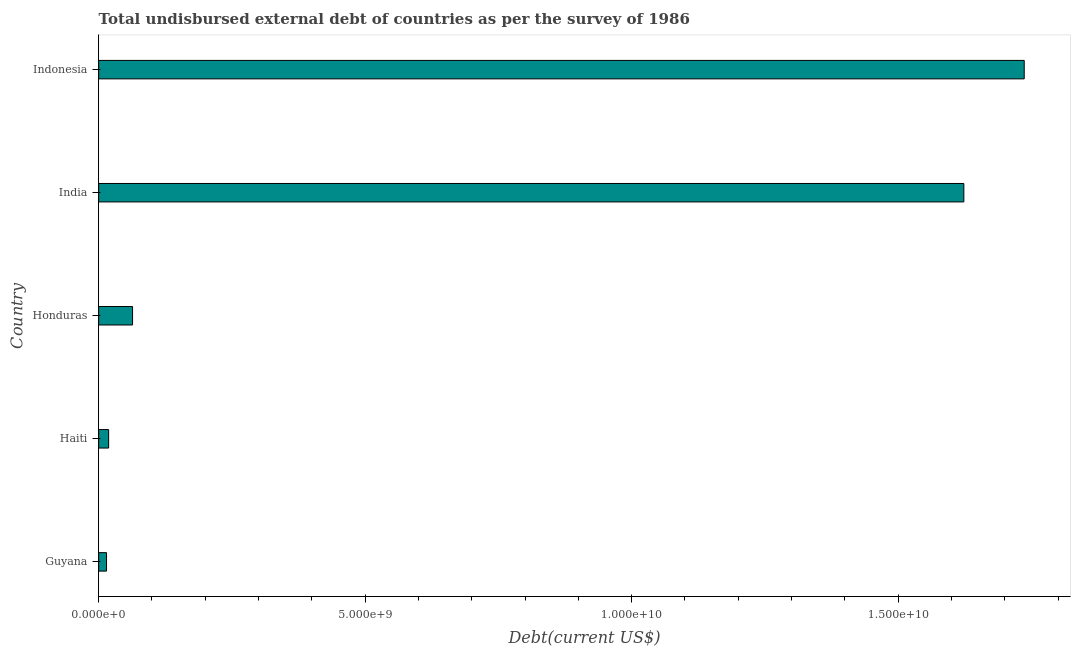What is the title of the graph?
Make the answer very short. Total undisbursed external debt of countries as per the survey of 1986. What is the label or title of the X-axis?
Ensure brevity in your answer.  Debt(current US$). What is the label or title of the Y-axis?
Make the answer very short. Country. What is the total debt in Guyana?
Offer a terse response. 1.48e+08. Across all countries, what is the maximum total debt?
Your answer should be very brief. 1.74e+1. Across all countries, what is the minimum total debt?
Your answer should be very brief. 1.48e+08. In which country was the total debt minimum?
Keep it short and to the point. Guyana. What is the sum of the total debt?
Provide a short and direct response. 3.46e+1. What is the difference between the total debt in Guyana and Honduras?
Your answer should be compact. -4.89e+08. What is the average total debt per country?
Your answer should be compact. 6.91e+09. What is the median total debt?
Your response must be concise. 6.37e+08. In how many countries, is the total debt greater than 14000000000 US$?
Your answer should be very brief. 2. What is the ratio of the total debt in Haiti to that in India?
Keep it short and to the point. 0.01. Is the total debt in Guyana less than that in Haiti?
Ensure brevity in your answer.  Yes. What is the difference between the highest and the second highest total debt?
Your response must be concise. 1.13e+09. Is the sum of the total debt in Guyana and Indonesia greater than the maximum total debt across all countries?
Your answer should be very brief. Yes. What is the difference between the highest and the lowest total debt?
Your answer should be very brief. 1.72e+1. In how many countries, is the total debt greater than the average total debt taken over all countries?
Your response must be concise. 2. How many bars are there?
Your answer should be compact. 5. How many countries are there in the graph?
Offer a very short reply. 5. What is the difference between two consecutive major ticks on the X-axis?
Give a very brief answer. 5.00e+09. Are the values on the major ticks of X-axis written in scientific E-notation?
Your answer should be compact. Yes. What is the Debt(current US$) in Guyana?
Your response must be concise. 1.48e+08. What is the Debt(current US$) in Haiti?
Ensure brevity in your answer.  1.88e+08. What is the Debt(current US$) in Honduras?
Keep it short and to the point. 6.37e+08. What is the Debt(current US$) of India?
Your answer should be very brief. 1.62e+1. What is the Debt(current US$) in Indonesia?
Offer a terse response. 1.74e+1. What is the difference between the Debt(current US$) in Guyana and Haiti?
Offer a terse response. -3.97e+07. What is the difference between the Debt(current US$) in Guyana and Honduras?
Offer a terse response. -4.89e+08. What is the difference between the Debt(current US$) in Guyana and India?
Provide a succinct answer. -1.61e+1. What is the difference between the Debt(current US$) in Guyana and Indonesia?
Keep it short and to the point. -1.72e+1. What is the difference between the Debt(current US$) in Haiti and Honduras?
Your response must be concise. -4.49e+08. What is the difference between the Debt(current US$) in Haiti and India?
Offer a terse response. -1.60e+1. What is the difference between the Debt(current US$) in Haiti and Indonesia?
Give a very brief answer. -1.72e+1. What is the difference between the Debt(current US$) in Honduras and India?
Your response must be concise. -1.56e+1. What is the difference between the Debt(current US$) in Honduras and Indonesia?
Keep it short and to the point. -1.67e+1. What is the difference between the Debt(current US$) in India and Indonesia?
Your answer should be compact. -1.13e+09. What is the ratio of the Debt(current US$) in Guyana to that in Haiti?
Offer a terse response. 0.79. What is the ratio of the Debt(current US$) in Guyana to that in Honduras?
Ensure brevity in your answer.  0.23. What is the ratio of the Debt(current US$) in Guyana to that in India?
Provide a succinct answer. 0.01. What is the ratio of the Debt(current US$) in Guyana to that in Indonesia?
Offer a very short reply. 0.01. What is the ratio of the Debt(current US$) in Haiti to that in Honduras?
Offer a very short reply. 0.29. What is the ratio of the Debt(current US$) in Haiti to that in India?
Provide a succinct answer. 0.01. What is the ratio of the Debt(current US$) in Haiti to that in Indonesia?
Your answer should be very brief. 0.01. What is the ratio of the Debt(current US$) in Honduras to that in India?
Offer a very short reply. 0.04. What is the ratio of the Debt(current US$) in Honduras to that in Indonesia?
Your answer should be very brief. 0.04. What is the ratio of the Debt(current US$) in India to that in Indonesia?
Your answer should be compact. 0.94. 